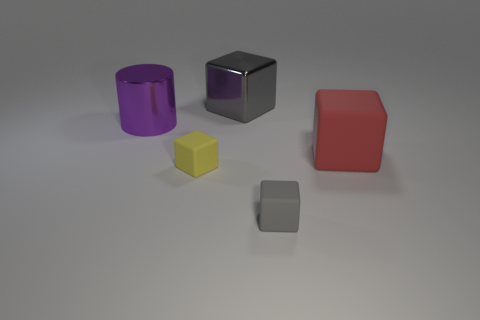Is there a big gray object of the same shape as the yellow object? Yes, there is a larger gray object that shares the same cube shape as the smaller yellow object. 